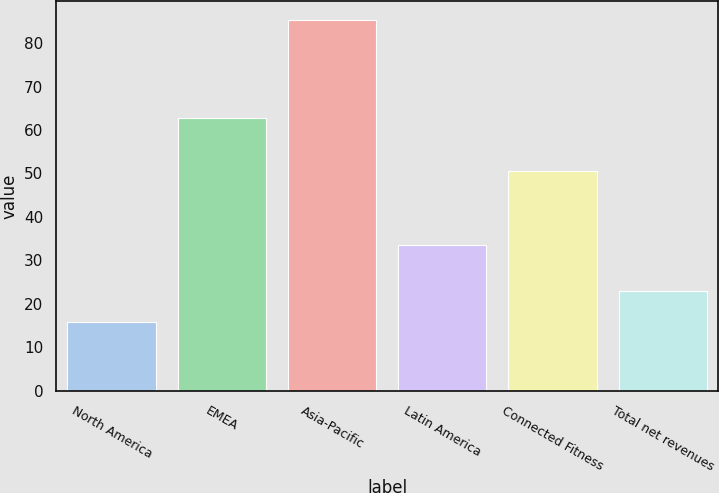<chart> <loc_0><loc_0><loc_500><loc_500><bar_chart><fcel>North America<fcel>EMEA<fcel>Asia-Pacific<fcel>Latin America<fcel>Connected Fitness<fcel>Total net revenues<nl><fcel>15.9<fcel>62.8<fcel>85.4<fcel>33.5<fcel>50.6<fcel>22.85<nl></chart> 